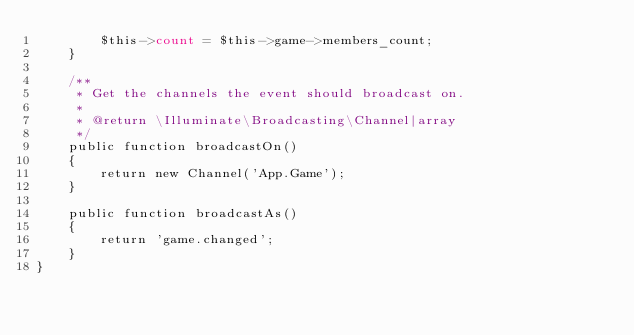<code> <loc_0><loc_0><loc_500><loc_500><_PHP_>        $this->count = $this->game->members_count;
    }

    /**
     * Get the channels the event should broadcast on.
     *
     * @return \Illuminate\Broadcasting\Channel|array
     */
    public function broadcastOn()
    {
        return new Channel('App.Game');
    }

    public function broadcastAs()
    {
        return 'game.changed';
    }
}
</code> 